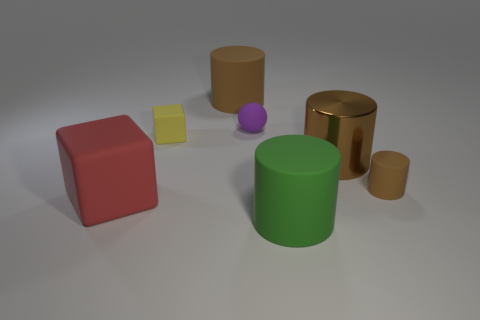Does the metal cylinder have the same color as the cylinder behind the small matte cube?
Offer a very short reply. Yes. There is a rubber thing that is right of the large brown matte cylinder and behind the small yellow object; what is its size?
Give a very brief answer. Small. What is the shape of the small brown object that is made of the same material as the large red cube?
Ensure brevity in your answer.  Cylinder. Are the small purple thing and the large cylinder that is in front of the tiny brown matte thing made of the same material?
Ensure brevity in your answer.  Yes. Are there any brown objects that are left of the large brown object that is on the left side of the tiny purple object?
Keep it short and to the point. No. There is a tiny yellow thing that is the same shape as the large red thing; what material is it?
Offer a very short reply. Rubber. How many big brown things are to the left of the big rubber cylinder that is in front of the small purple sphere?
Keep it short and to the point. 1. Are there any other things that are the same color as the small sphere?
Offer a very short reply. No. How many things are either blue cylinders or cylinders behind the purple rubber object?
Provide a short and direct response. 1. There is a big brown thing that is on the right side of the purple rubber ball that is in front of the brown rubber cylinder that is behind the small brown object; what is its material?
Provide a short and direct response. Metal. 